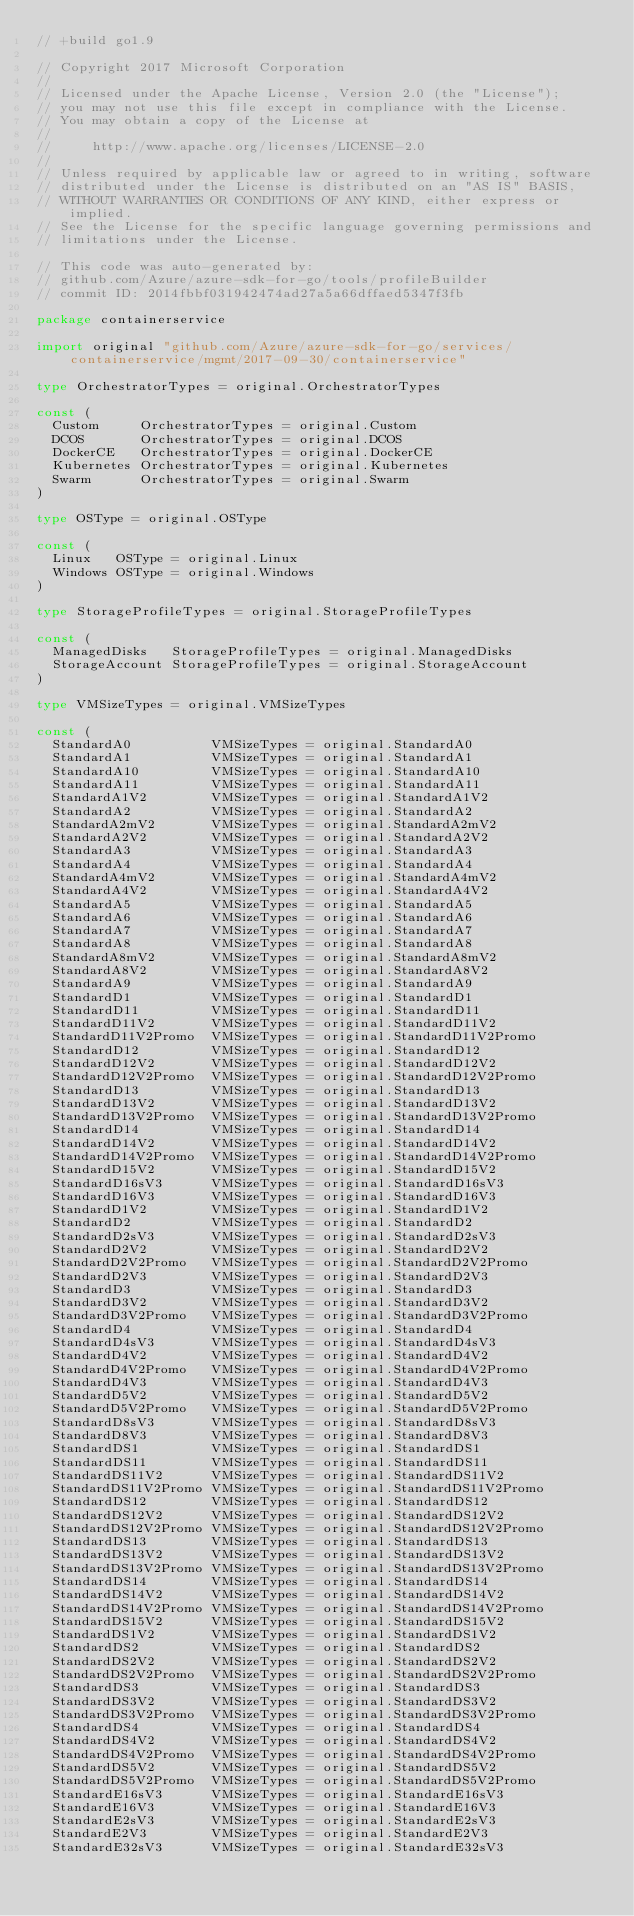<code> <loc_0><loc_0><loc_500><loc_500><_Go_>// +build go1.9

// Copyright 2017 Microsoft Corporation
//
// Licensed under the Apache License, Version 2.0 (the "License");
// you may not use this file except in compliance with the License.
// You may obtain a copy of the License at
//
//     http://www.apache.org/licenses/LICENSE-2.0
//
// Unless required by applicable law or agreed to in writing, software
// distributed under the License is distributed on an "AS IS" BASIS,
// WITHOUT WARRANTIES OR CONDITIONS OF ANY KIND, either express or implied.
// See the License for the specific language governing permissions and
// limitations under the License.

// This code was auto-generated by:
// github.com/Azure/azure-sdk-for-go/tools/profileBuilder
// commit ID: 2014fbbf031942474ad27a5a66dffaed5347f3fb

package containerservice

import original "github.com/Azure/azure-sdk-for-go/services/containerservice/mgmt/2017-09-30/containerservice"

type OrchestratorTypes = original.OrchestratorTypes

const (
	Custom     OrchestratorTypes = original.Custom
	DCOS       OrchestratorTypes = original.DCOS
	DockerCE   OrchestratorTypes = original.DockerCE
	Kubernetes OrchestratorTypes = original.Kubernetes
	Swarm      OrchestratorTypes = original.Swarm
)

type OSType = original.OSType

const (
	Linux   OSType = original.Linux
	Windows OSType = original.Windows
)

type StorageProfileTypes = original.StorageProfileTypes

const (
	ManagedDisks   StorageProfileTypes = original.ManagedDisks
	StorageAccount StorageProfileTypes = original.StorageAccount
)

type VMSizeTypes = original.VMSizeTypes

const (
	StandardA0          VMSizeTypes = original.StandardA0
	StandardA1          VMSizeTypes = original.StandardA1
	StandardA10         VMSizeTypes = original.StandardA10
	StandardA11         VMSizeTypes = original.StandardA11
	StandardA1V2        VMSizeTypes = original.StandardA1V2
	StandardA2          VMSizeTypes = original.StandardA2
	StandardA2mV2       VMSizeTypes = original.StandardA2mV2
	StandardA2V2        VMSizeTypes = original.StandardA2V2
	StandardA3          VMSizeTypes = original.StandardA3
	StandardA4          VMSizeTypes = original.StandardA4
	StandardA4mV2       VMSizeTypes = original.StandardA4mV2
	StandardA4V2        VMSizeTypes = original.StandardA4V2
	StandardA5          VMSizeTypes = original.StandardA5
	StandardA6          VMSizeTypes = original.StandardA6
	StandardA7          VMSizeTypes = original.StandardA7
	StandardA8          VMSizeTypes = original.StandardA8
	StandardA8mV2       VMSizeTypes = original.StandardA8mV2
	StandardA8V2        VMSizeTypes = original.StandardA8V2
	StandardA9          VMSizeTypes = original.StandardA9
	StandardD1          VMSizeTypes = original.StandardD1
	StandardD11         VMSizeTypes = original.StandardD11
	StandardD11V2       VMSizeTypes = original.StandardD11V2
	StandardD11V2Promo  VMSizeTypes = original.StandardD11V2Promo
	StandardD12         VMSizeTypes = original.StandardD12
	StandardD12V2       VMSizeTypes = original.StandardD12V2
	StandardD12V2Promo  VMSizeTypes = original.StandardD12V2Promo
	StandardD13         VMSizeTypes = original.StandardD13
	StandardD13V2       VMSizeTypes = original.StandardD13V2
	StandardD13V2Promo  VMSizeTypes = original.StandardD13V2Promo
	StandardD14         VMSizeTypes = original.StandardD14
	StandardD14V2       VMSizeTypes = original.StandardD14V2
	StandardD14V2Promo  VMSizeTypes = original.StandardD14V2Promo
	StandardD15V2       VMSizeTypes = original.StandardD15V2
	StandardD16sV3      VMSizeTypes = original.StandardD16sV3
	StandardD16V3       VMSizeTypes = original.StandardD16V3
	StandardD1V2        VMSizeTypes = original.StandardD1V2
	StandardD2          VMSizeTypes = original.StandardD2
	StandardD2sV3       VMSizeTypes = original.StandardD2sV3
	StandardD2V2        VMSizeTypes = original.StandardD2V2
	StandardD2V2Promo   VMSizeTypes = original.StandardD2V2Promo
	StandardD2V3        VMSizeTypes = original.StandardD2V3
	StandardD3          VMSizeTypes = original.StandardD3
	StandardD3V2        VMSizeTypes = original.StandardD3V2
	StandardD3V2Promo   VMSizeTypes = original.StandardD3V2Promo
	StandardD4          VMSizeTypes = original.StandardD4
	StandardD4sV3       VMSizeTypes = original.StandardD4sV3
	StandardD4V2        VMSizeTypes = original.StandardD4V2
	StandardD4V2Promo   VMSizeTypes = original.StandardD4V2Promo
	StandardD4V3        VMSizeTypes = original.StandardD4V3
	StandardD5V2        VMSizeTypes = original.StandardD5V2
	StandardD5V2Promo   VMSizeTypes = original.StandardD5V2Promo
	StandardD8sV3       VMSizeTypes = original.StandardD8sV3
	StandardD8V3        VMSizeTypes = original.StandardD8V3
	StandardDS1         VMSizeTypes = original.StandardDS1
	StandardDS11        VMSizeTypes = original.StandardDS11
	StandardDS11V2      VMSizeTypes = original.StandardDS11V2
	StandardDS11V2Promo VMSizeTypes = original.StandardDS11V2Promo
	StandardDS12        VMSizeTypes = original.StandardDS12
	StandardDS12V2      VMSizeTypes = original.StandardDS12V2
	StandardDS12V2Promo VMSizeTypes = original.StandardDS12V2Promo
	StandardDS13        VMSizeTypes = original.StandardDS13
	StandardDS13V2      VMSizeTypes = original.StandardDS13V2
	StandardDS13V2Promo VMSizeTypes = original.StandardDS13V2Promo
	StandardDS14        VMSizeTypes = original.StandardDS14
	StandardDS14V2      VMSizeTypes = original.StandardDS14V2
	StandardDS14V2Promo VMSizeTypes = original.StandardDS14V2Promo
	StandardDS15V2      VMSizeTypes = original.StandardDS15V2
	StandardDS1V2       VMSizeTypes = original.StandardDS1V2
	StandardDS2         VMSizeTypes = original.StandardDS2
	StandardDS2V2       VMSizeTypes = original.StandardDS2V2
	StandardDS2V2Promo  VMSizeTypes = original.StandardDS2V2Promo
	StandardDS3         VMSizeTypes = original.StandardDS3
	StandardDS3V2       VMSizeTypes = original.StandardDS3V2
	StandardDS3V2Promo  VMSizeTypes = original.StandardDS3V2Promo
	StandardDS4         VMSizeTypes = original.StandardDS4
	StandardDS4V2       VMSizeTypes = original.StandardDS4V2
	StandardDS4V2Promo  VMSizeTypes = original.StandardDS4V2Promo
	StandardDS5V2       VMSizeTypes = original.StandardDS5V2
	StandardDS5V2Promo  VMSizeTypes = original.StandardDS5V2Promo
	StandardE16sV3      VMSizeTypes = original.StandardE16sV3
	StandardE16V3       VMSizeTypes = original.StandardE16V3
	StandardE2sV3       VMSizeTypes = original.StandardE2sV3
	StandardE2V3        VMSizeTypes = original.StandardE2V3
	StandardE32sV3      VMSizeTypes = original.StandardE32sV3</code> 